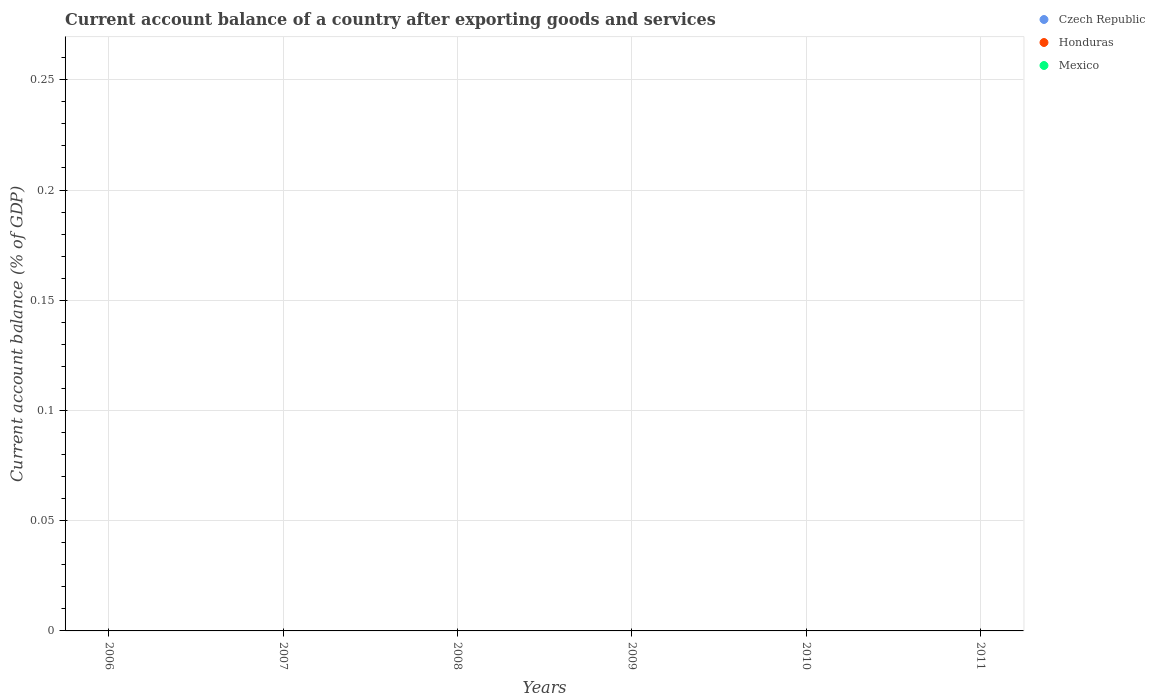How many different coloured dotlines are there?
Your response must be concise. 0. Is the number of dotlines equal to the number of legend labels?
Offer a very short reply. No. Across all years, what is the minimum account balance in Honduras?
Offer a very short reply. 0. What is the total account balance in Czech Republic in the graph?
Provide a short and direct response. 0. What is the difference between the account balance in Mexico in 2007 and the account balance in Czech Republic in 2008?
Keep it short and to the point. 0. In how many years, is the account balance in Czech Republic greater than 0.060000000000000005 %?
Offer a terse response. 0. In how many years, is the account balance in Czech Republic greater than the average account balance in Czech Republic taken over all years?
Offer a very short reply. 0. Does the account balance in Mexico monotonically increase over the years?
Offer a very short reply. No. How many dotlines are there?
Offer a very short reply. 0. How many years are there in the graph?
Provide a succinct answer. 6. Are the values on the major ticks of Y-axis written in scientific E-notation?
Make the answer very short. No. Does the graph contain any zero values?
Offer a very short reply. Yes. Where does the legend appear in the graph?
Offer a very short reply. Top right. How many legend labels are there?
Offer a very short reply. 3. How are the legend labels stacked?
Keep it short and to the point. Vertical. What is the title of the graph?
Provide a short and direct response. Current account balance of a country after exporting goods and services. Does "Kazakhstan" appear as one of the legend labels in the graph?
Offer a very short reply. No. What is the label or title of the Y-axis?
Your answer should be very brief. Current account balance (% of GDP). What is the Current account balance (% of GDP) in Honduras in 2006?
Make the answer very short. 0. What is the Current account balance (% of GDP) of Honduras in 2007?
Your answer should be very brief. 0. What is the Current account balance (% of GDP) in Honduras in 2008?
Your answer should be compact. 0. What is the Current account balance (% of GDP) in Mexico in 2009?
Your answer should be compact. 0. What is the Current account balance (% of GDP) in Honduras in 2010?
Your answer should be very brief. 0. What is the Current account balance (% of GDP) in Mexico in 2010?
Offer a terse response. 0. What is the Current account balance (% of GDP) of Honduras in 2011?
Give a very brief answer. 0. What is the total Current account balance (% of GDP) in Czech Republic in the graph?
Your answer should be compact. 0. What is the total Current account balance (% of GDP) of Honduras in the graph?
Offer a very short reply. 0. What is the average Current account balance (% of GDP) in Honduras per year?
Make the answer very short. 0. 